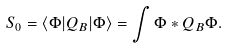<formula> <loc_0><loc_0><loc_500><loc_500>S _ { 0 } = \langle \Phi | Q _ { B } | \Phi \rangle = \int \Phi * Q _ { B } \Phi .</formula> 